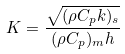Convert formula to latex. <formula><loc_0><loc_0><loc_500><loc_500>K = \frac { \sqrt { ( \rho C _ { p } k ) _ { s } } } { ( \rho C _ { p } ) _ { m } h }</formula> 